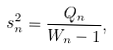Convert formula to latex. <formula><loc_0><loc_0><loc_500><loc_500>s _ { n } ^ { 2 } = { \frac { Q _ { n } } { W _ { n } - 1 } } ,</formula> 